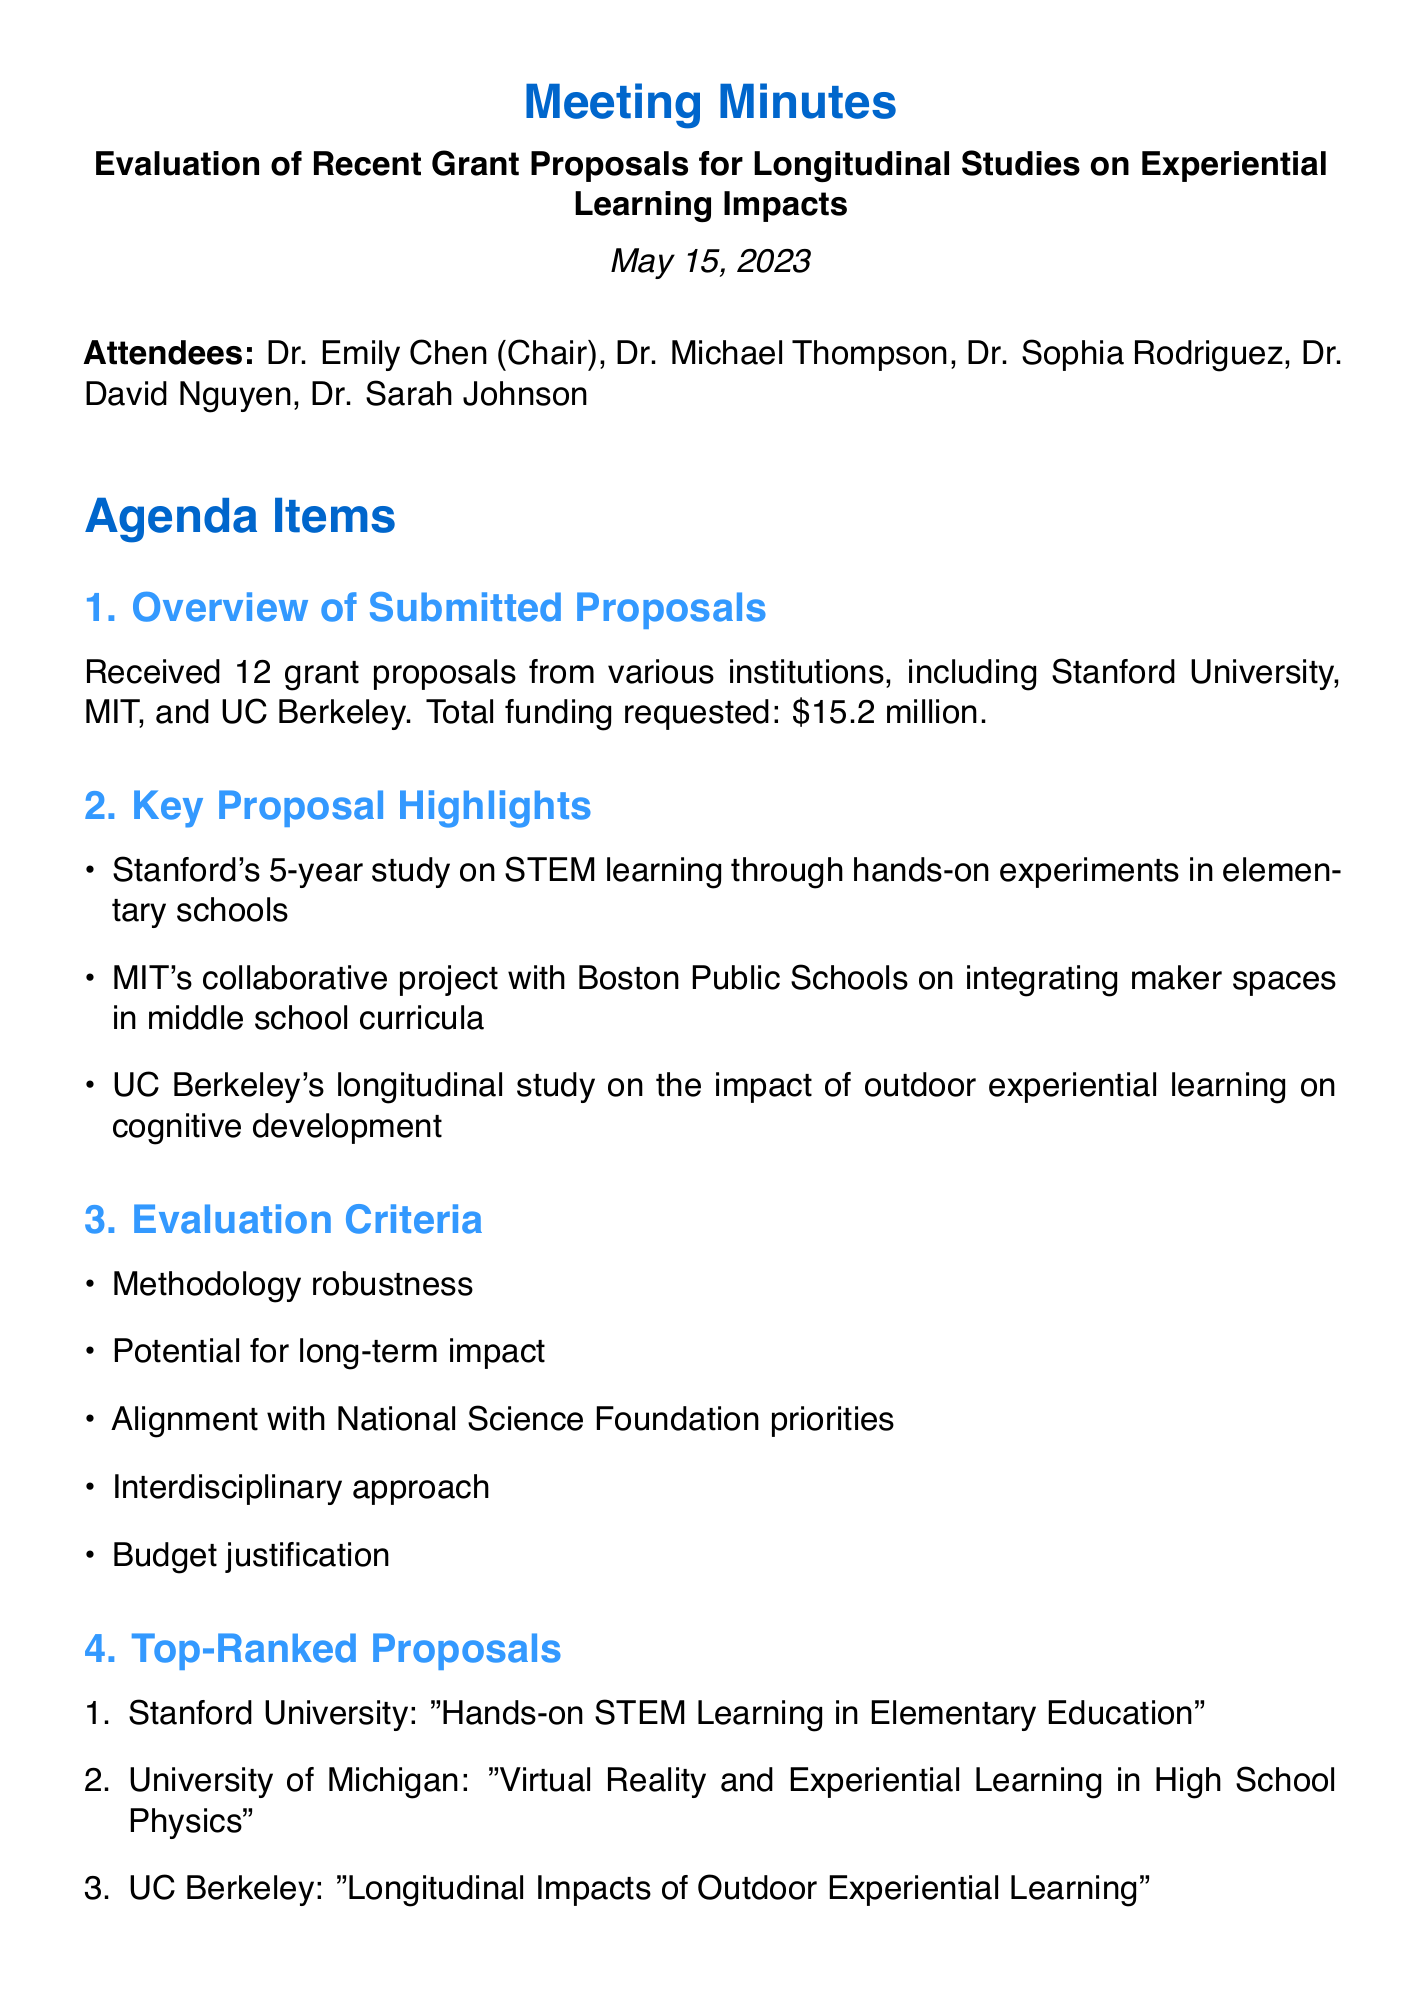What is the date of the meeting? The date of the meeting is given in the document as May 15, 2023.
Answer: May 15, 2023 How many grant proposals were received? The document states that 12 grant proposals were received from various institutions.
Answer: 12 Which institution proposed a study on outdoor experiential learning? The document lists UC Berkeley as the institution conducting a longitudinal study on outdoor experiential learning.
Answer: UC Berkeley What is the total funding requested? The total funding requested is mentioned as $15.2 million in the document.
Answer: $15.2 million Who is the chair of the meeting? The document specifies that Dr. Emily Chen is the chair of the meeting.
Answer: Dr. Emily Chen What are the top-ranked proposals primarily focused on? The top-ranked proposals include hands-on STEM learning, virtual reality in high school physics, and outdoor experiential learning, indicating a focus on experiential education.
Answer: Experiential education When is the recommendation report due? The document states the recommendation report for the NSF review board is due by June 30, 2023.
Answer: June 30, 2023 What are the evaluation criteria for the proposals? The document lists five evaluation criteria: methodology robustness, potential for long-term impact, alignment with NSF priorities, interdisciplinary approach, and budget justification.
Answer: Methodology robustness, potential for long-term impact, alignment with NSF priorities, interdisciplinary approach, budget justification Who is responsible for drafting the initial recommendation report? Dr. Nguyen is assigned to draft the initial recommendation report, as mentioned in the action items.
Answer: Dr. Nguyen 